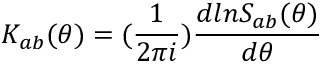Convert formula to latex. <formula><loc_0><loc_0><loc_500><loc_500>K _ { a b } ( \theta ) = ( { \frac { 1 } { 2 \pi i } } ) { \frac { d \ln S _ { a b } ( \theta ) } { d \theta } }</formula> 